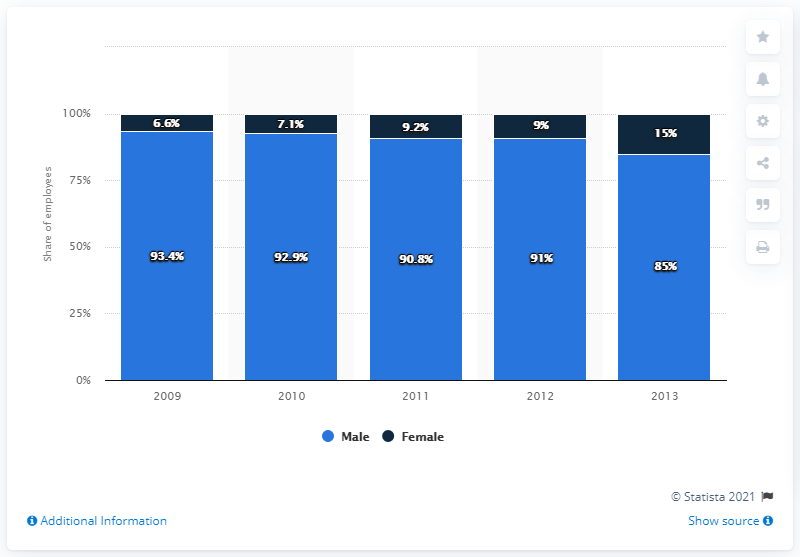Draw attention to some important aspects in this diagram. In 2013, the ratio of female to male was 0.176470588... Female gender is the least. 